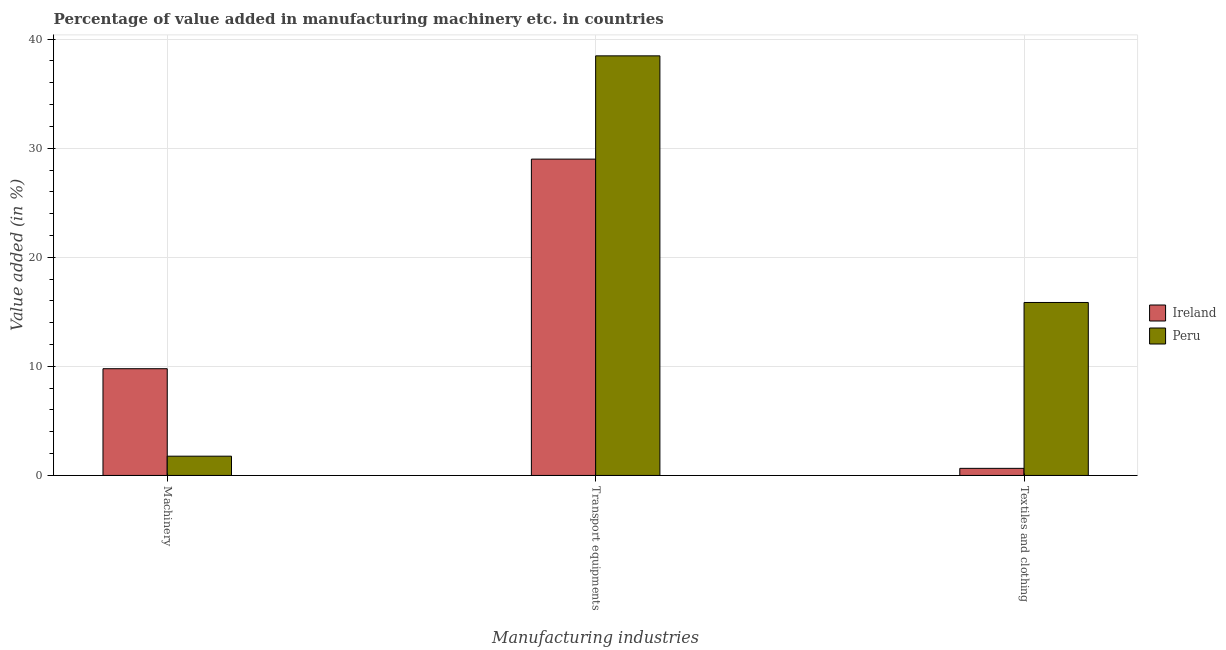How many different coloured bars are there?
Keep it short and to the point. 2. Are the number of bars on each tick of the X-axis equal?
Provide a succinct answer. Yes. What is the label of the 1st group of bars from the left?
Give a very brief answer. Machinery. What is the value added in manufacturing machinery in Ireland?
Offer a very short reply. 9.79. Across all countries, what is the maximum value added in manufacturing transport equipments?
Offer a terse response. 38.47. Across all countries, what is the minimum value added in manufacturing transport equipments?
Your answer should be very brief. 29. In which country was the value added in manufacturing machinery maximum?
Your answer should be very brief. Ireland. What is the total value added in manufacturing machinery in the graph?
Your response must be concise. 11.55. What is the difference between the value added in manufacturing machinery in Peru and that in Ireland?
Make the answer very short. -8.02. What is the difference between the value added in manufacturing machinery in Ireland and the value added in manufacturing textile and clothing in Peru?
Your answer should be compact. -6.07. What is the average value added in manufacturing transport equipments per country?
Provide a succinct answer. 33.74. What is the difference between the value added in manufacturing transport equipments and value added in manufacturing machinery in Ireland?
Your answer should be compact. 19.22. What is the ratio of the value added in manufacturing textile and clothing in Peru to that in Ireland?
Offer a terse response. 24.39. Is the value added in manufacturing machinery in Ireland less than that in Peru?
Provide a short and direct response. No. Is the difference between the value added in manufacturing transport equipments in Ireland and Peru greater than the difference between the value added in manufacturing textile and clothing in Ireland and Peru?
Give a very brief answer. Yes. What is the difference between the highest and the second highest value added in manufacturing machinery?
Ensure brevity in your answer.  8.02. What is the difference between the highest and the lowest value added in manufacturing transport equipments?
Make the answer very short. 9.47. Is the sum of the value added in manufacturing machinery in Peru and Ireland greater than the maximum value added in manufacturing transport equipments across all countries?
Provide a succinct answer. No. What does the 2nd bar from the left in Textiles and clothing represents?
Offer a terse response. Peru. What does the 2nd bar from the right in Machinery represents?
Ensure brevity in your answer.  Ireland. How many countries are there in the graph?
Provide a succinct answer. 2. Are the values on the major ticks of Y-axis written in scientific E-notation?
Your answer should be compact. No. Does the graph contain grids?
Your answer should be very brief. Yes. How many legend labels are there?
Your answer should be compact. 2. What is the title of the graph?
Your answer should be compact. Percentage of value added in manufacturing machinery etc. in countries. Does "United Arab Emirates" appear as one of the legend labels in the graph?
Provide a short and direct response. No. What is the label or title of the X-axis?
Give a very brief answer. Manufacturing industries. What is the label or title of the Y-axis?
Ensure brevity in your answer.  Value added (in %). What is the Value added (in %) in Ireland in Machinery?
Your answer should be compact. 9.79. What is the Value added (in %) in Peru in Machinery?
Keep it short and to the point. 1.77. What is the Value added (in %) in Ireland in Transport equipments?
Provide a short and direct response. 29. What is the Value added (in %) of Peru in Transport equipments?
Your answer should be very brief. 38.47. What is the Value added (in %) of Ireland in Textiles and clothing?
Your response must be concise. 0.65. What is the Value added (in %) in Peru in Textiles and clothing?
Offer a very short reply. 15.86. Across all Manufacturing industries, what is the maximum Value added (in %) in Ireland?
Your answer should be compact. 29. Across all Manufacturing industries, what is the maximum Value added (in %) in Peru?
Offer a very short reply. 38.47. Across all Manufacturing industries, what is the minimum Value added (in %) of Ireland?
Make the answer very short. 0.65. Across all Manufacturing industries, what is the minimum Value added (in %) of Peru?
Keep it short and to the point. 1.77. What is the total Value added (in %) of Ireland in the graph?
Keep it short and to the point. 39.44. What is the total Value added (in %) of Peru in the graph?
Your answer should be very brief. 56.09. What is the difference between the Value added (in %) in Ireland in Machinery and that in Transport equipments?
Your answer should be compact. -19.22. What is the difference between the Value added (in %) in Peru in Machinery and that in Transport equipments?
Make the answer very short. -36.7. What is the difference between the Value added (in %) of Ireland in Machinery and that in Textiles and clothing?
Provide a short and direct response. 9.14. What is the difference between the Value added (in %) in Peru in Machinery and that in Textiles and clothing?
Your answer should be compact. -14.09. What is the difference between the Value added (in %) of Ireland in Transport equipments and that in Textiles and clothing?
Make the answer very short. 28.35. What is the difference between the Value added (in %) in Peru in Transport equipments and that in Textiles and clothing?
Your answer should be very brief. 22.61. What is the difference between the Value added (in %) of Ireland in Machinery and the Value added (in %) of Peru in Transport equipments?
Your answer should be compact. -28.68. What is the difference between the Value added (in %) in Ireland in Machinery and the Value added (in %) in Peru in Textiles and clothing?
Your answer should be very brief. -6.07. What is the difference between the Value added (in %) in Ireland in Transport equipments and the Value added (in %) in Peru in Textiles and clothing?
Provide a succinct answer. 13.14. What is the average Value added (in %) of Ireland per Manufacturing industries?
Ensure brevity in your answer.  13.15. What is the average Value added (in %) of Peru per Manufacturing industries?
Offer a terse response. 18.7. What is the difference between the Value added (in %) of Ireland and Value added (in %) of Peru in Machinery?
Ensure brevity in your answer.  8.02. What is the difference between the Value added (in %) of Ireland and Value added (in %) of Peru in Transport equipments?
Ensure brevity in your answer.  -9.47. What is the difference between the Value added (in %) of Ireland and Value added (in %) of Peru in Textiles and clothing?
Provide a succinct answer. -15.21. What is the ratio of the Value added (in %) of Ireland in Machinery to that in Transport equipments?
Keep it short and to the point. 0.34. What is the ratio of the Value added (in %) in Peru in Machinery to that in Transport equipments?
Your answer should be very brief. 0.05. What is the ratio of the Value added (in %) of Ireland in Machinery to that in Textiles and clothing?
Your answer should be compact. 15.05. What is the ratio of the Value added (in %) in Peru in Machinery to that in Textiles and clothing?
Give a very brief answer. 0.11. What is the ratio of the Value added (in %) in Ireland in Transport equipments to that in Textiles and clothing?
Provide a short and direct response. 44.61. What is the ratio of the Value added (in %) of Peru in Transport equipments to that in Textiles and clothing?
Give a very brief answer. 2.43. What is the difference between the highest and the second highest Value added (in %) of Ireland?
Your answer should be compact. 19.22. What is the difference between the highest and the second highest Value added (in %) in Peru?
Provide a succinct answer. 22.61. What is the difference between the highest and the lowest Value added (in %) in Ireland?
Provide a short and direct response. 28.35. What is the difference between the highest and the lowest Value added (in %) of Peru?
Provide a succinct answer. 36.7. 